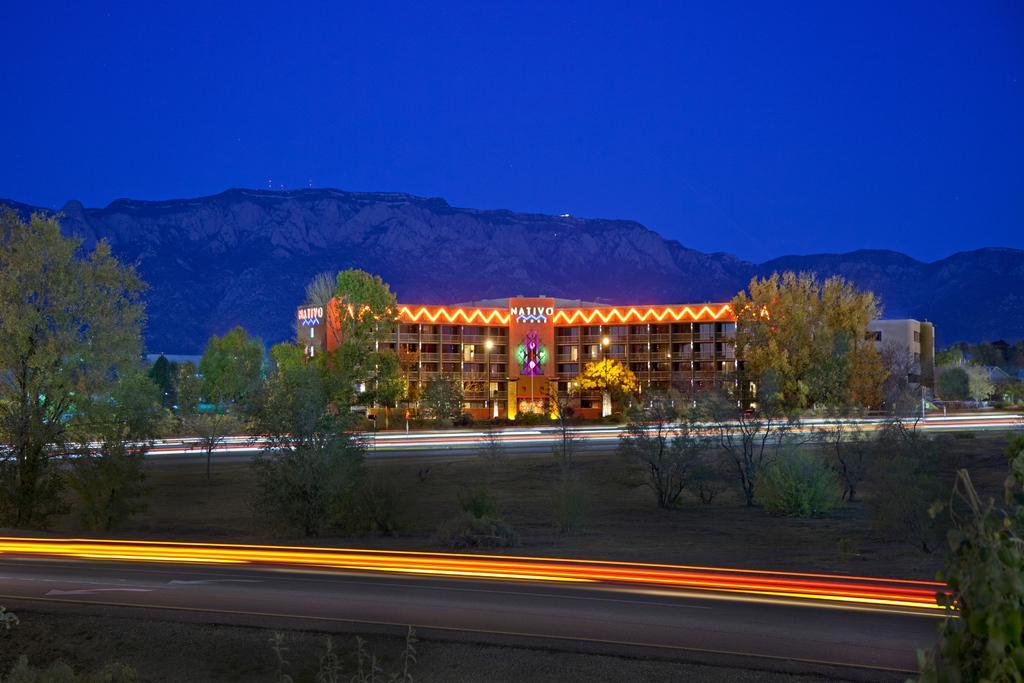Please provide a concise description of this image. In this image we can see laser lights, trees, grass, building, lights, hill and blue sky.  